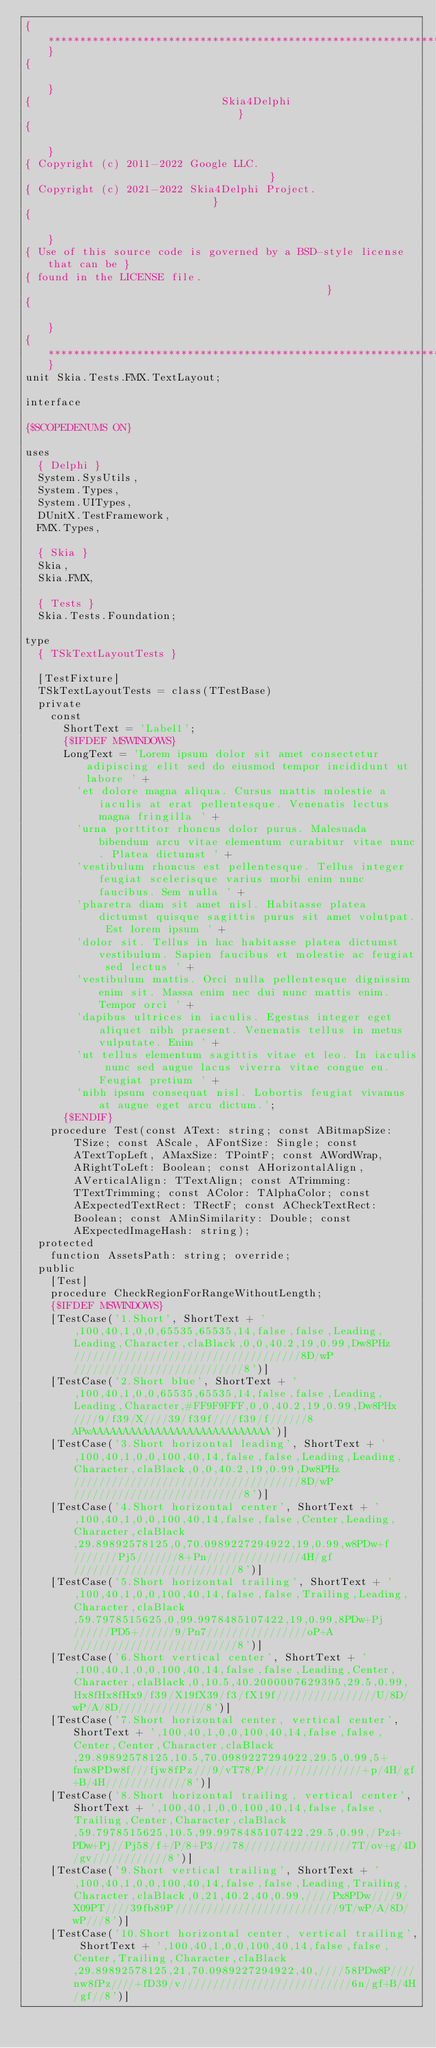Convert code to text. <code><loc_0><loc_0><loc_500><loc_500><_Pascal_>{************************************************************************}
{                                                                        }
{                              Skia4Delphi                               }
{                                                                        }
{ Copyright (c) 2011-2022 Google LLC.                                    }
{ Copyright (c) 2021-2022 Skia4Delphi Project.                           }
{                                                                        }
{ Use of this source code is governed by a BSD-style license that can be }
{ found in the LICENSE file.                                             }
{                                                                        }
{************************************************************************}
unit Skia.Tests.FMX.TextLayout;

interface

{$SCOPEDENUMS ON}

uses
  { Delphi }
  System.SysUtils,
  System.Types,
  System.UITypes,
  DUnitX.TestFramework,
  FMX.Types,

  { Skia }
  Skia,
  Skia.FMX,

  { Tests }
  Skia.Tests.Foundation;

type
  { TSkTextLayoutTests }

  [TestFixture]
  TSkTextLayoutTests = class(TTestBase)
  private
    const
      ShortText = 'Label1';
      {$IFDEF MSWINDOWS}
      LongText = 'Lorem ipsum dolor sit amet consectetur adipiscing elit sed do eiusmod tempor incididunt ut labore ' +
        'et dolore magna aliqua. Cursus mattis molestie a iaculis at erat pellentesque. Venenatis lectus magna fringilla ' +
        'urna porttitor rhoncus dolor purus. Malesuada bibendum arcu vitae elementum curabitur vitae nunc. Platea dictumst ' +
        'vestibulum rhoncus est pellentesque. Tellus integer feugiat scelerisque varius morbi enim nunc faucibus. Sem nulla ' +
        'pharetra diam sit amet nisl. Habitasse platea dictumst quisque sagittis purus sit amet volutpat. Est lorem ipsum ' +
        'dolor sit. Tellus in hac habitasse platea dictumst vestibulum. Sapien faucibus et molestie ac feugiat sed lectus ' +
        'vestibulum mattis. Orci nulla pellentesque dignissim enim sit. Massa enim nec dui nunc mattis enim. Tempor orci ' +
        'dapibus ultrices in iaculis. Egestas integer eget aliquet nibh praesent. Venenatis tellus in metus vulputate. Enim ' +
        'ut tellus elementum sagittis vitae et leo. In iaculis nunc sed augue lacus viverra vitae congue eu. Feugiat pretium ' +
        'nibh ipsum consequat nisl. Lobortis feugiat vivamus at augue eget arcu dictum.';
      {$ENDIF}
    procedure Test(const AText: string; const ABitmapSize: TSize; const AScale, AFontSize: Single; const ATextTopLeft, AMaxSize: TPointF; const AWordWrap, ARightToLeft: Boolean; const AHorizontalAlign, AVerticalAlign: TTextAlign; const ATrimming: TTextTrimming; const AColor: TAlphaColor; const AExpectedTextRect: TRectF; const ACheckTextRect: Boolean; const AMinSimilarity: Double; const AExpectedImageHash: string);
  protected
    function AssetsPath: string; override;
  public
    [Test]
    procedure CheckRegionForRangeWithoutLength;
    {$IFDEF MSWINDOWS}
    [TestCase('1.Short', ShortText + ',100,40,1,0,0,65535,65535,14,false,false,Leading,Leading,Character,claBlack,0,0,40.2,19,0.99,Dw8PHz////////////////////////////////////8D/wP///////////////////////////8')]
    [TestCase('2.Short blue', ShortText + ',100,40,1,0,0,65535,65535,14,false,false,Leading,Leading,Character,#FF9F9FFF,0,0,40.2,19,0.99,Dw8PHx////9/f39/X////39/f39f////f39/f//////8APwAAAAAAAAAAAAAAAAAAAAAAAAAAAA')]
    [TestCase('3.Short horizontal leading', ShortText + ',100,40,1,0,0,100,40,14,false,false,Leading,Leading,Character,claBlack,0,0,40.2,19,0.99,Dw8PHz////////////////////////////////////8D/wP///////////////////////////8')]
    [TestCase('4.Short horizontal center', ShortText + ',100,40,1,0,0,100,40,14,false,false,Center,Leading,Character,claBlack,29.89892578125,0,70.0989227294922,19,0.99,w8PDw+f///////Pj5///////8+Pn///////////////4H/gf//////////////////////////8')]
    [TestCase('5.Short horizontal trailing', ShortText + ',100,40,1,0,0,100,40,14,false,false,Trailing,Leading,Character,claBlack,59.7978515625,0,99.9978485107422,19,0.99,8PDw+Pj//////PD5+//////9/Pn7////////////////oP+A//////////////////////////8')]
    [TestCase('6.Short vertical center', ShortText + ',100,40,1,0,0,100,40,14,false,false,Leading,Center,Character,claBlack,0,10.5,40.2000007629395,29.5,0.99,Hx8fHx8fHx9/f39/X19fX39/f3/fX19f////////////////U/8D/wP/A/8D//////////////8')]
    [TestCase('7.Short horizontal center, vertical center', ShortText + ',100,40,1,0,0,100,40,14,false,false,Center,Center,Character,claBlack,29.89892578125,10.5,70.0989227294922,29.5,0.99,5+fnw8PDw8f///fjw8fPz///9/vT78/P////////////////+p/4H/gf+B/4H/////////////8')]
    [TestCase('8.Short horizontal trailing, vertical center', ShortText + ',100,40,1,0,0,100,40,14,false,false,Trailing,Center,Character,claBlack,59.7978515625,10.5,99.9978485107422,29.5,0.99,/Pz4+PDw+Pj//Pj58/f+/P/8+P3///78/////////////////7T/ov+g/4D/gv////////////8')]
    [TestCase('9.Short vertical trailing', ShortText + ',100,40,1,0,0,100,40,14,false,false,Leading,Trailing,Character,claBlack,0,21,40.2,40,0.99,////Px8PDw////9/X09PT////39fb89P//////////////////////////9T/wP/A/8D/wP///8')]
    [TestCase('10.Short horizontal center, vertical trailing', ShortText + ',100,40,1,0,0,100,40,14,false,false,Center,Trailing,Character,claBlack,29.89892578125,21,70.0989227294922,40,////58PDw8P////nw8fPz////+fD39/v///////////////////////////6n/gf+B/4H/gf//8')]</code> 